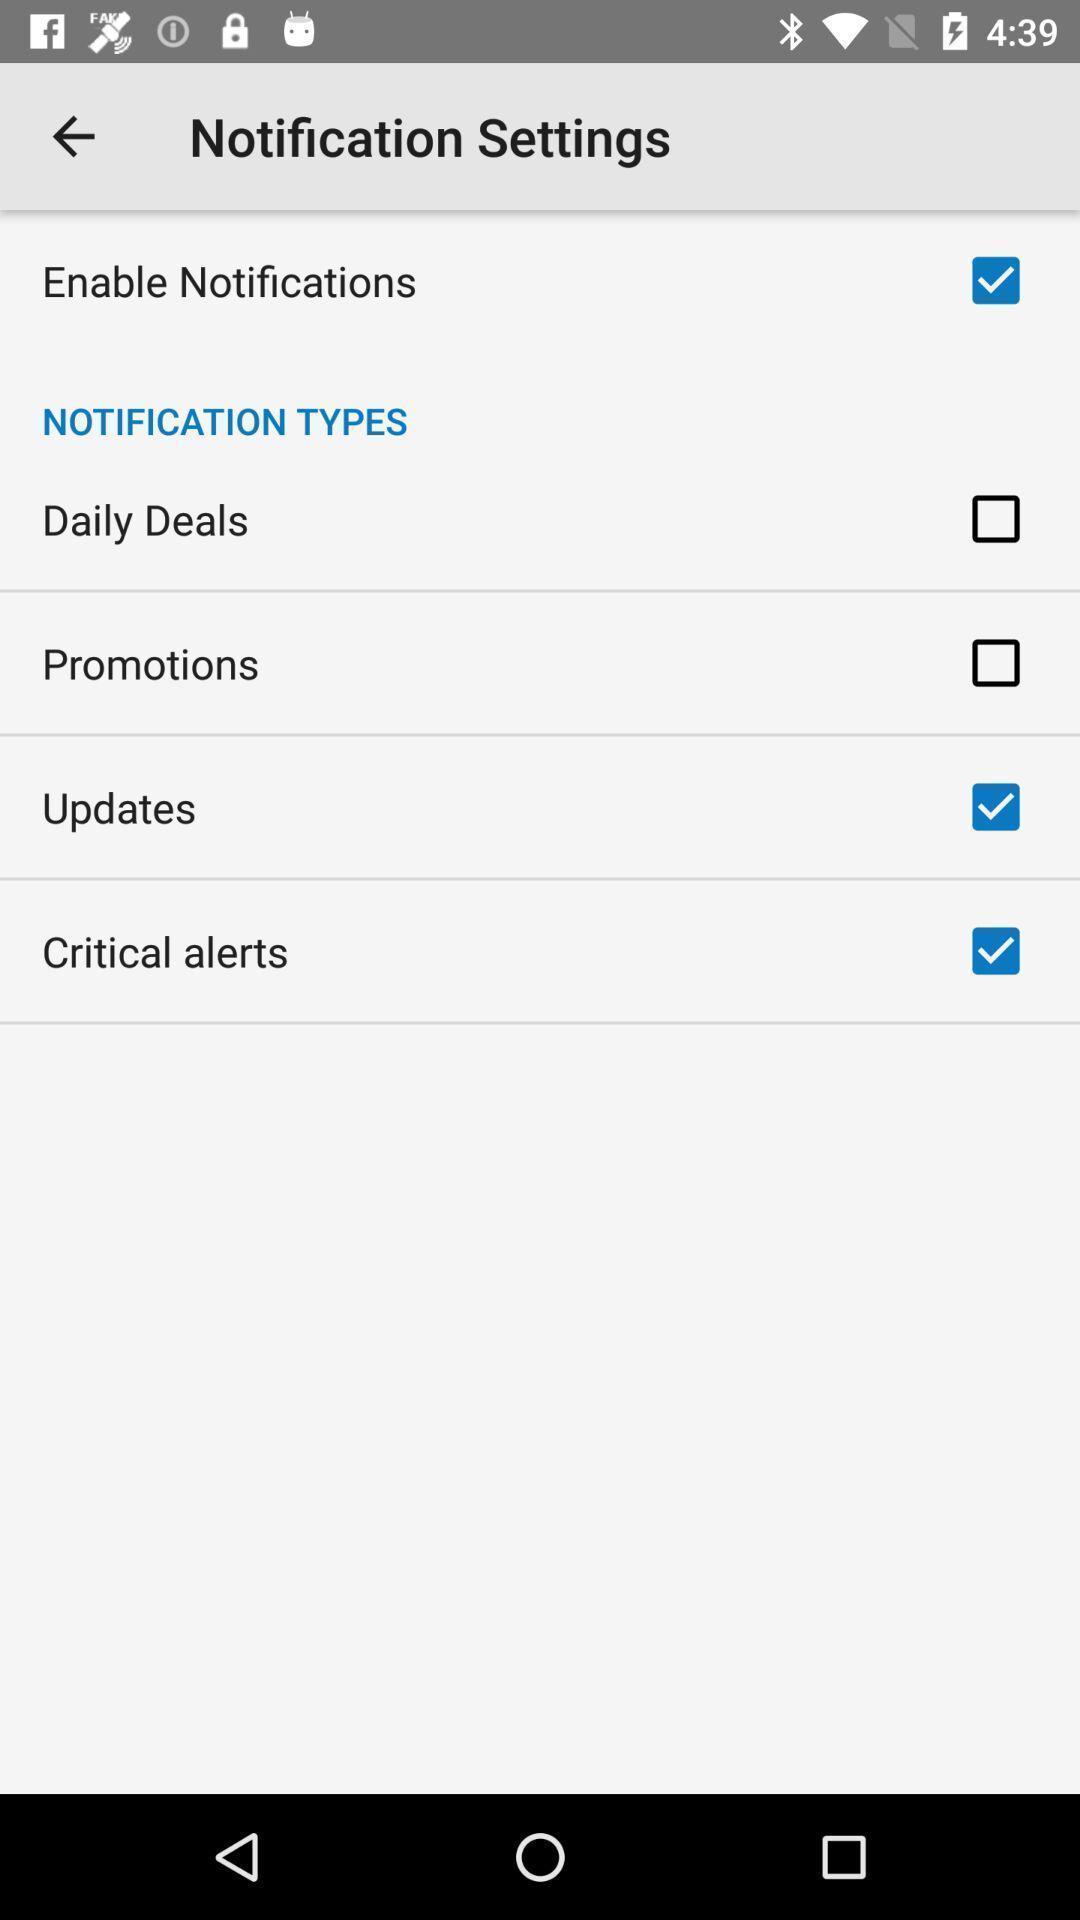Give me a summary of this screen capture. Screen showing notification setting options. 